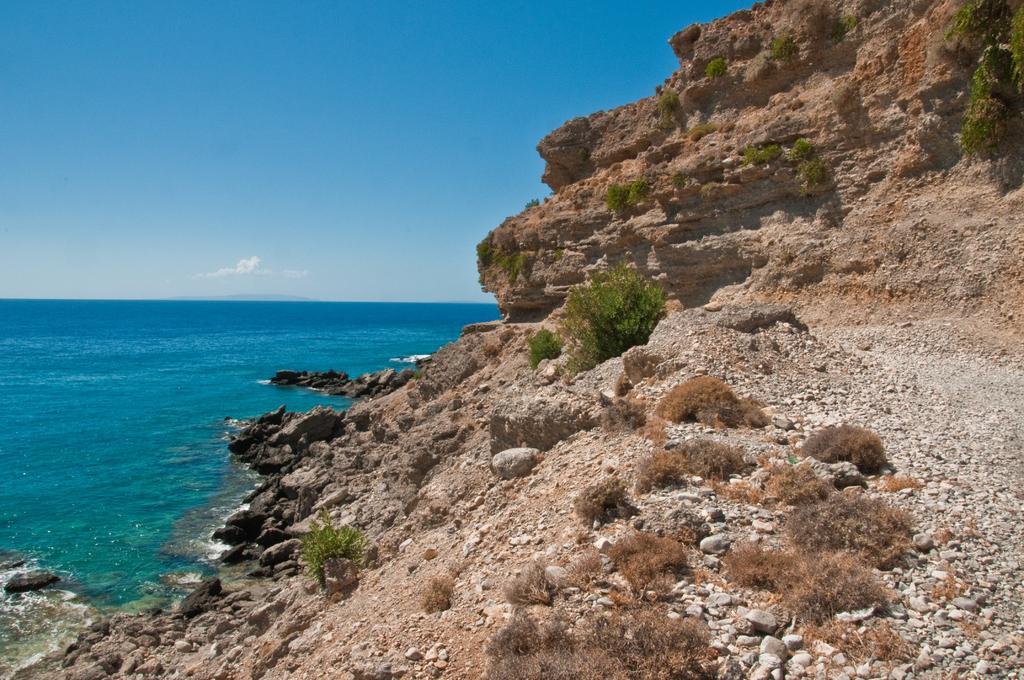In one or two sentences, can you explain what this image depicts? In this picture I can see the ocean. On the right I can see the mountain and grass. At the bottom I can see small stones. At the top I can see the sky and clouds. 